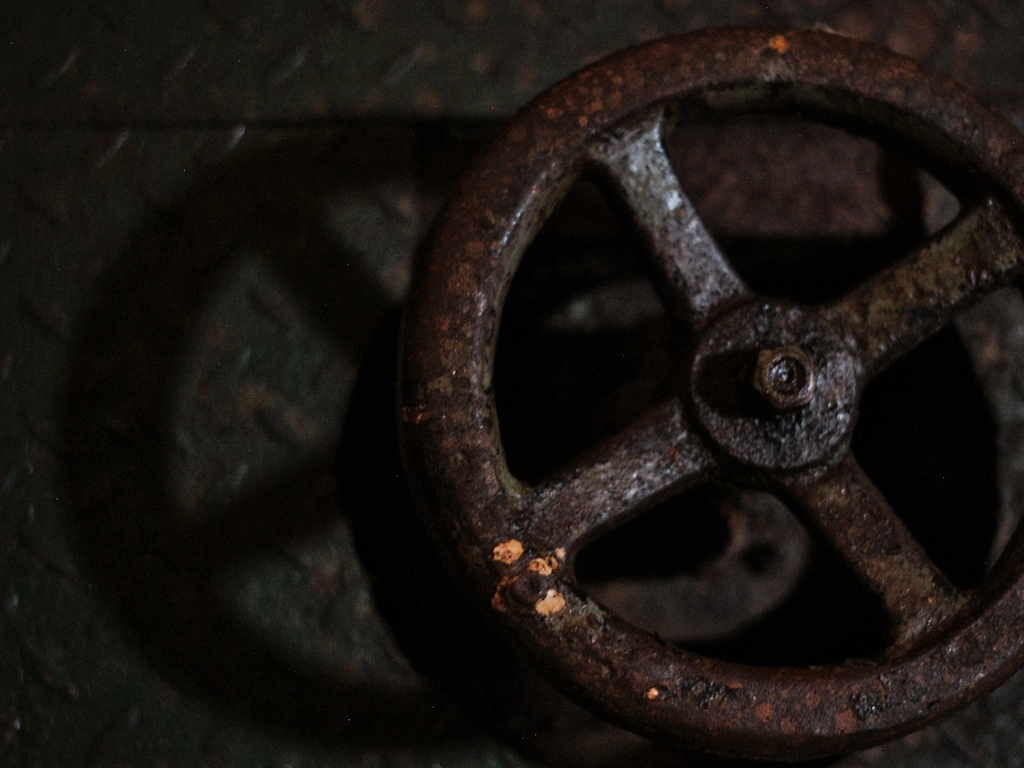What historical period does this object suggest? The rusty appearance and design of the valve wheel suggest an industrial context, potentially from the late 19th to mid-20th century. It hints at an era where such robust metal mechanisms were commonly used in machinery. 